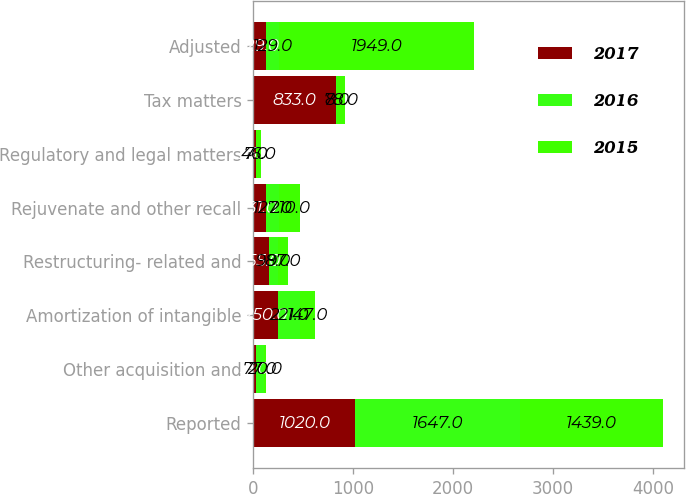Convert chart. <chart><loc_0><loc_0><loc_500><loc_500><stacked_bar_chart><ecel><fcel>Reported<fcel>Other acquisition and<fcel>Amortization of intangible<fcel>Restructuring- related and<fcel>Rejuvenate and other recall<fcel>Regulatory and legal matters<fcel>Tax matters<fcel>Adjusted<nl><fcel>2017<fcel>1020<fcel>31<fcel>250<fcel>155<fcel>131<fcel>25<fcel>833<fcel>129<nl><fcel>2016<fcel>1647<fcel>77<fcel>221<fcel>98<fcel>127<fcel>7<fcel>8<fcel>129<nl><fcel>2015<fcel>1439<fcel>20<fcel>147<fcel>97<fcel>210<fcel>46<fcel>78<fcel>1949<nl></chart> 